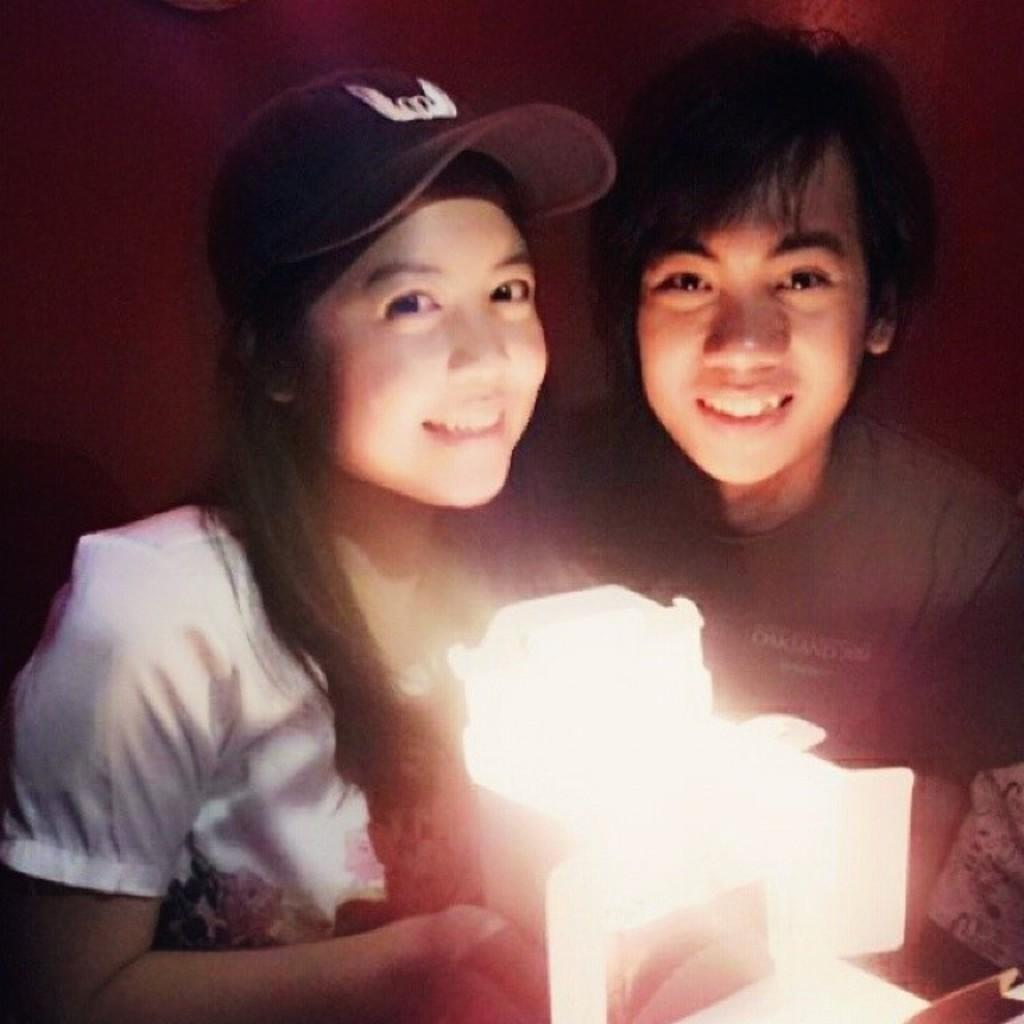Who is present in the image? There is a man and a woman in the image. What are the man and woman doing in the image? The man and woman are holding an object that emits light. What can be seen in the background of the image? There is a well in the background of the image. What type of soup is being prepared in the image? There is no soup present in the image; the man and woman are holding an object that emits light. 